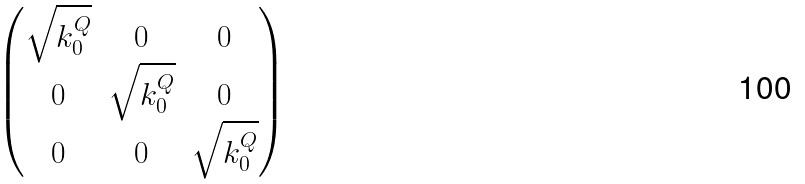<formula> <loc_0><loc_0><loc_500><loc_500>\begin{pmatrix} \sqrt { k _ { 0 } ^ { Q } } & 0 & 0 \\ 0 & \sqrt { k _ { 0 } ^ { Q } } & 0 \\ 0 & 0 & \sqrt { k _ { 0 } ^ { Q } } \end{pmatrix}</formula> 